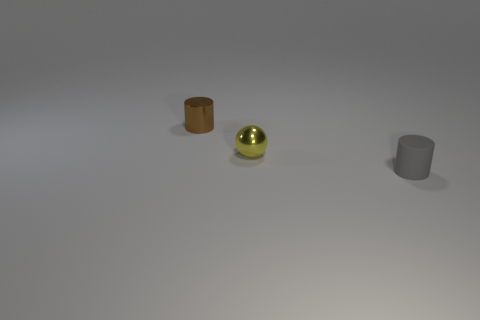What shape is the thing that is right of the shiny object that is right of the cylinder that is behind the tiny rubber cylinder?
Provide a succinct answer. Cylinder. Do the ball and the cylinder left of the small gray matte cylinder have the same size?
Offer a terse response. Yes. Are there any yellow metal spheres that have the same size as the brown cylinder?
Ensure brevity in your answer.  Yes. What number of other objects are the same material as the tiny gray cylinder?
Provide a succinct answer. 0. What color is the object that is right of the brown metallic object and behind the small matte cylinder?
Offer a very short reply. Yellow. Are the tiny cylinder left of the tiny matte cylinder and the yellow thing right of the brown thing made of the same material?
Provide a succinct answer. Yes. There is a object that is on the left side of the yellow shiny thing; does it have the same size as the ball?
Offer a terse response. Yes. What is the shape of the small yellow object?
Keep it short and to the point. Sphere. How many things are small cylinders behind the metal ball or tiny yellow metallic objects?
Your answer should be compact. 2. Are there more yellow metal balls behind the gray rubber cylinder than small green metallic cylinders?
Offer a very short reply. Yes. 